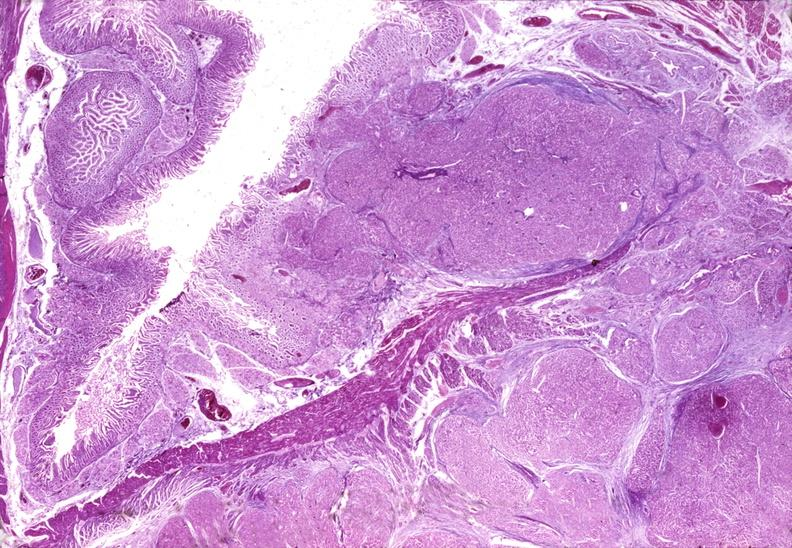s pancreas present?
Answer the question using a single word or phrase. Yes 